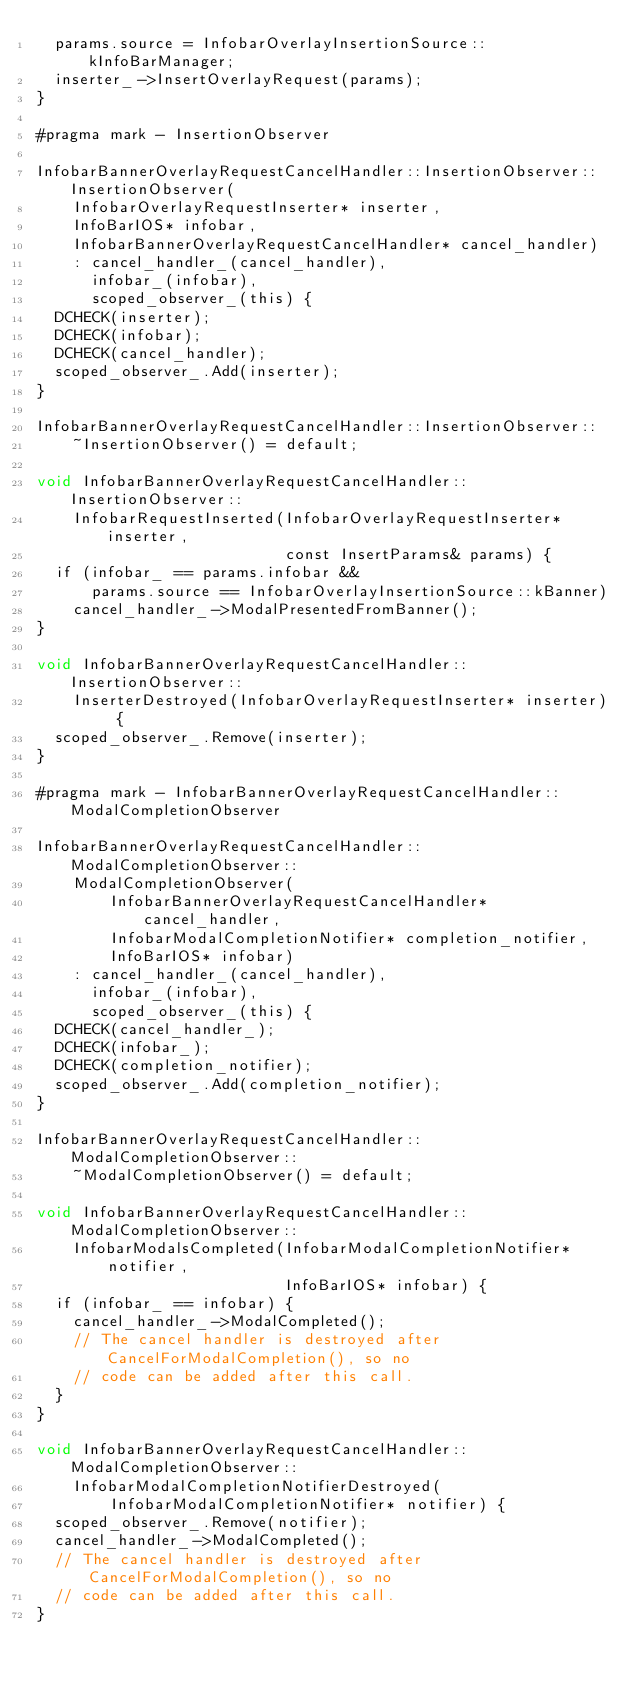Convert code to text. <code><loc_0><loc_0><loc_500><loc_500><_ObjectiveC_>  params.source = InfobarOverlayInsertionSource::kInfoBarManager;
  inserter_->InsertOverlayRequest(params);
}

#pragma mark - InsertionObserver

InfobarBannerOverlayRequestCancelHandler::InsertionObserver::InsertionObserver(
    InfobarOverlayRequestInserter* inserter,
    InfoBarIOS* infobar,
    InfobarBannerOverlayRequestCancelHandler* cancel_handler)
    : cancel_handler_(cancel_handler),
      infobar_(infobar),
      scoped_observer_(this) {
  DCHECK(inserter);
  DCHECK(infobar);
  DCHECK(cancel_handler);
  scoped_observer_.Add(inserter);
}

InfobarBannerOverlayRequestCancelHandler::InsertionObserver::
    ~InsertionObserver() = default;

void InfobarBannerOverlayRequestCancelHandler::InsertionObserver::
    InfobarRequestInserted(InfobarOverlayRequestInserter* inserter,
                           const InsertParams& params) {
  if (infobar_ == params.infobar &&
      params.source == InfobarOverlayInsertionSource::kBanner)
    cancel_handler_->ModalPresentedFromBanner();
}

void InfobarBannerOverlayRequestCancelHandler::InsertionObserver::
    InserterDestroyed(InfobarOverlayRequestInserter* inserter) {
  scoped_observer_.Remove(inserter);
}

#pragma mark - InfobarBannerOverlayRequestCancelHandler::ModalCompletionObserver

InfobarBannerOverlayRequestCancelHandler::ModalCompletionObserver::
    ModalCompletionObserver(
        InfobarBannerOverlayRequestCancelHandler* cancel_handler,
        InfobarModalCompletionNotifier* completion_notifier,
        InfoBarIOS* infobar)
    : cancel_handler_(cancel_handler),
      infobar_(infobar),
      scoped_observer_(this) {
  DCHECK(cancel_handler_);
  DCHECK(infobar_);
  DCHECK(completion_notifier);
  scoped_observer_.Add(completion_notifier);
}

InfobarBannerOverlayRequestCancelHandler::ModalCompletionObserver::
    ~ModalCompletionObserver() = default;

void InfobarBannerOverlayRequestCancelHandler::ModalCompletionObserver::
    InfobarModalsCompleted(InfobarModalCompletionNotifier* notifier,
                           InfoBarIOS* infobar) {
  if (infobar_ == infobar) {
    cancel_handler_->ModalCompleted();
    // The cancel handler is destroyed after CancelForModalCompletion(), so no
    // code can be added after this call.
  }
}

void InfobarBannerOverlayRequestCancelHandler::ModalCompletionObserver::
    InfobarModalCompletionNotifierDestroyed(
        InfobarModalCompletionNotifier* notifier) {
  scoped_observer_.Remove(notifier);
  cancel_handler_->ModalCompleted();
  // The cancel handler is destroyed after CancelForModalCompletion(), so no
  // code can be added after this call.
}
</code> 